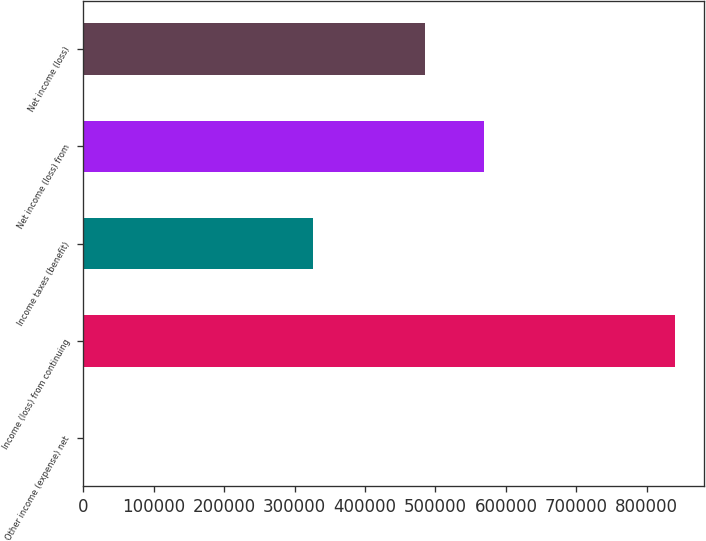Convert chart to OTSL. <chart><loc_0><loc_0><loc_500><loc_500><bar_chart><fcel>Other income (expense) net<fcel>Income (loss) from continuing<fcel>Income taxes (benefit)<fcel>Net income (loss) from<fcel>Net income (loss)<nl><fcel>501<fcel>839370<fcel>326315<fcel>569560<fcel>485673<nl></chart> 